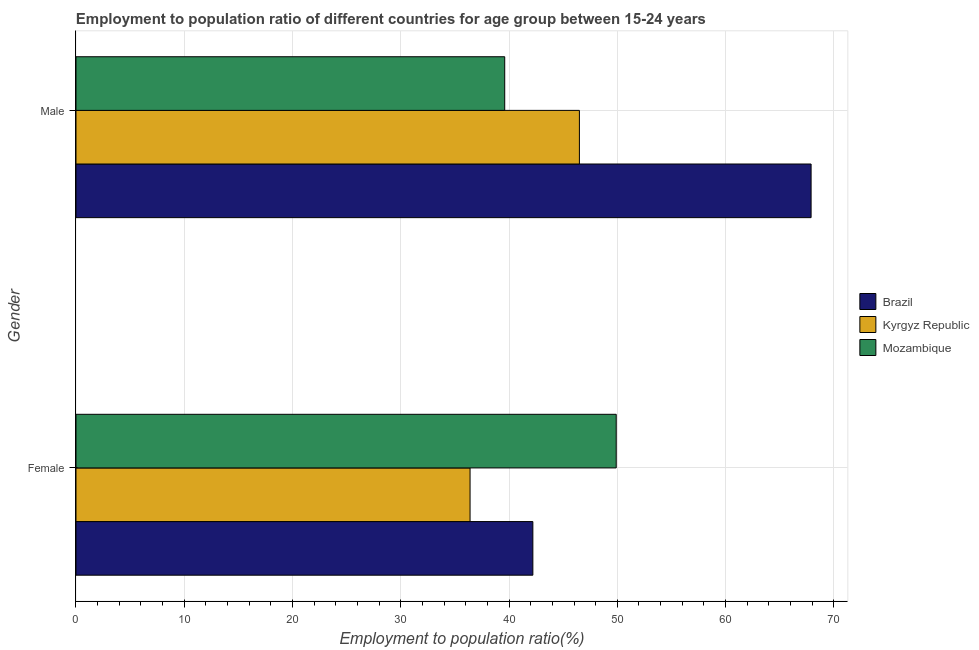Are the number of bars per tick equal to the number of legend labels?
Offer a very short reply. Yes. How many bars are there on the 2nd tick from the top?
Ensure brevity in your answer.  3. How many bars are there on the 1st tick from the bottom?
Give a very brief answer. 3. What is the employment to population ratio(male) in Brazil?
Provide a short and direct response. 67.9. Across all countries, what is the maximum employment to population ratio(male)?
Offer a very short reply. 67.9. Across all countries, what is the minimum employment to population ratio(male)?
Ensure brevity in your answer.  39.6. In which country was the employment to population ratio(male) maximum?
Your answer should be compact. Brazil. In which country was the employment to population ratio(male) minimum?
Provide a short and direct response. Mozambique. What is the total employment to population ratio(female) in the graph?
Your answer should be very brief. 128.5. What is the difference between the employment to population ratio(male) in Kyrgyz Republic and that in Mozambique?
Keep it short and to the point. 6.9. What is the difference between the employment to population ratio(male) in Brazil and the employment to population ratio(female) in Mozambique?
Your answer should be compact. 18. What is the average employment to population ratio(male) per country?
Provide a short and direct response. 51.33. What is the difference between the employment to population ratio(female) and employment to population ratio(male) in Brazil?
Provide a succinct answer. -25.7. What is the ratio of the employment to population ratio(male) in Brazil to that in Mozambique?
Ensure brevity in your answer.  1.71. In how many countries, is the employment to population ratio(male) greater than the average employment to population ratio(male) taken over all countries?
Make the answer very short. 1. What does the 1st bar from the top in Female represents?
Your response must be concise. Mozambique. What does the 2nd bar from the bottom in Male represents?
Provide a succinct answer. Kyrgyz Republic. How many bars are there?
Your response must be concise. 6. Are the values on the major ticks of X-axis written in scientific E-notation?
Offer a terse response. No. Does the graph contain any zero values?
Your answer should be compact. No. Does the graph contain grids?
Keep it short and to the point. Yes. How are the legend labels stacked?
Provide a succinct answer. Vertical. What is the title of the graph?
Provide a short and direct response. Employment to population ratio of different countries for age group between 15-24 years. What is the Employment to population ratio(%) in Brazil in Female?
Keep it short and to the point. 42.2. What is the Employment to population ratio(%) in Kyrgyz Republic in Female?
Your answer should be compact. 36.4. What is the Employment to population ratio(%) in Mozambique in Female?
Your answer should be compact. 49.9. What is the Employment to population ratio(%) of Brazil in Male?
Your response must be concise. 67.9. What is the Employment to population ratio(%) in Kyrgyz Republic in Male?
Ensure brevity in your answer.  46.5. What is the Employment to population ratio(%) of Mozambique in Male?
Provide a short and direct response. 39.6. Across all Gender, what is the maximum Employment to population ratio(%) in Brazil?
Give a very brief answer. 67.9. Across all Gender, what is the maximum Employment to population ratio(%) of Kyrgyz Republic?
Give a very brief answer. 46.5. Across all Gender, what is the maximum Employment to population ratio(%) in Mozambique?
Give a very brief answer. 49.9. Across all Gender, what is the minimum Employment to population ratio(%) of Brazil?
Your answer should be very brief. 42.2. Across all Gender, what is the minimum Employment to population ratio(%) of Kyrgyz Republic?
Keep it short and to the point. 36.4. Across all Gender, what is the minimum Employment to population ratio(%) of Mozambique?
Keep it short and to the point. 39.6. What is the total Employment to population ratio(%) in Brazil in the graph?
Provide a succinct answer. 110.1. What is the total Employment to population ratio(%) in Kyrgyz Republic in the graph?
Provide a succinct answer. 82.9. What is the total Employment to population ratio(%) of Mozambique in the graph?
Keep it short and to the point. 89.5. What is the difference between the Employment to population ratio(%) of Brazil in Female and that in Male?
Keep it short and to the point. -25.7. What is the difference between the Employment to population ratio(%) in Kyrgyz Republic in Female and that in Male?
Offer a terse response. -10.1. What is the difference between the Employment to population ratio(%) of Kyrgyz Republic in Female and the Employment to population ratio(%) of Mozambique in Male?
Ensure brevity in your answer.  -3.2. What is the average Employment to population ratio(%) of Brazil per Gender?
Your answer should be very brief. 55.05. What is the average Employment to population ratio(%) in Kyrgyz Republic per Gender?
Provide a succinct answer. 41.45. What is the average Employment to population ratio(%) in Mozambique per Gender?
Provide a short and direct response. 44.75. What is the difference between the Employment to population ratio(%) in Brazil and Employment to population ratio(%) in Kyrgyz Republic in Male?
Provide a short and direct response. 21.4. What is the difference between the Employment to population ratio(%) of Brazil and Employment to population ratio(%) of Mozambique in Male?
Your answer should be compact. 28.3. What is the ratio of the Employment to population ratio(%) in Brazil in Female to that in Male?
Offer a terse response. 0.62. What is the ratio of the Employment to population ratio(%) in Kyrgyz Republic in Female to that in Male?
Your response must be concise. 0.78. What is the ratio of the Employment to population ratio(%) in Mozambique in Female to that in Male?
Offer a very short reply. 1.26. What is the difference between the highest and the second highest Employment to population ratio(%) of Brazil?
Keep it short and to the point. 25.7. What is the difference between the highest and the second highest Employment to population ratio(%) in Kyrgyz Republic?
Offer a very short reply. 10.1. What is the difference between the highest and the lowest Employment to population ratio(%) of Brazil?
Your response must be concise. 25.7. What is the difference between the highest and the lowest Employment to population ratio(%) in Mozambique?
Offer a terse response. 10.3. 